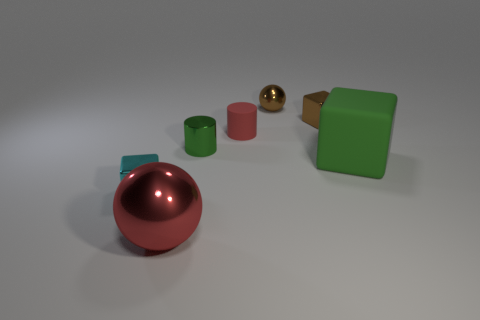Add 3 large cylinders. How many objects exist? 10 Subtract all spheres. How many objects are left? 5 Add 3 big green things. How many big green things are left? 4 Add 7 tiny red matte objects. How many tiny red matte objects exist? 8 Subtract 0 gray cubes. How many objects are left? 7 Subtract all cyan blocks. Subtract all brown cubes. How many objects are left? 5 